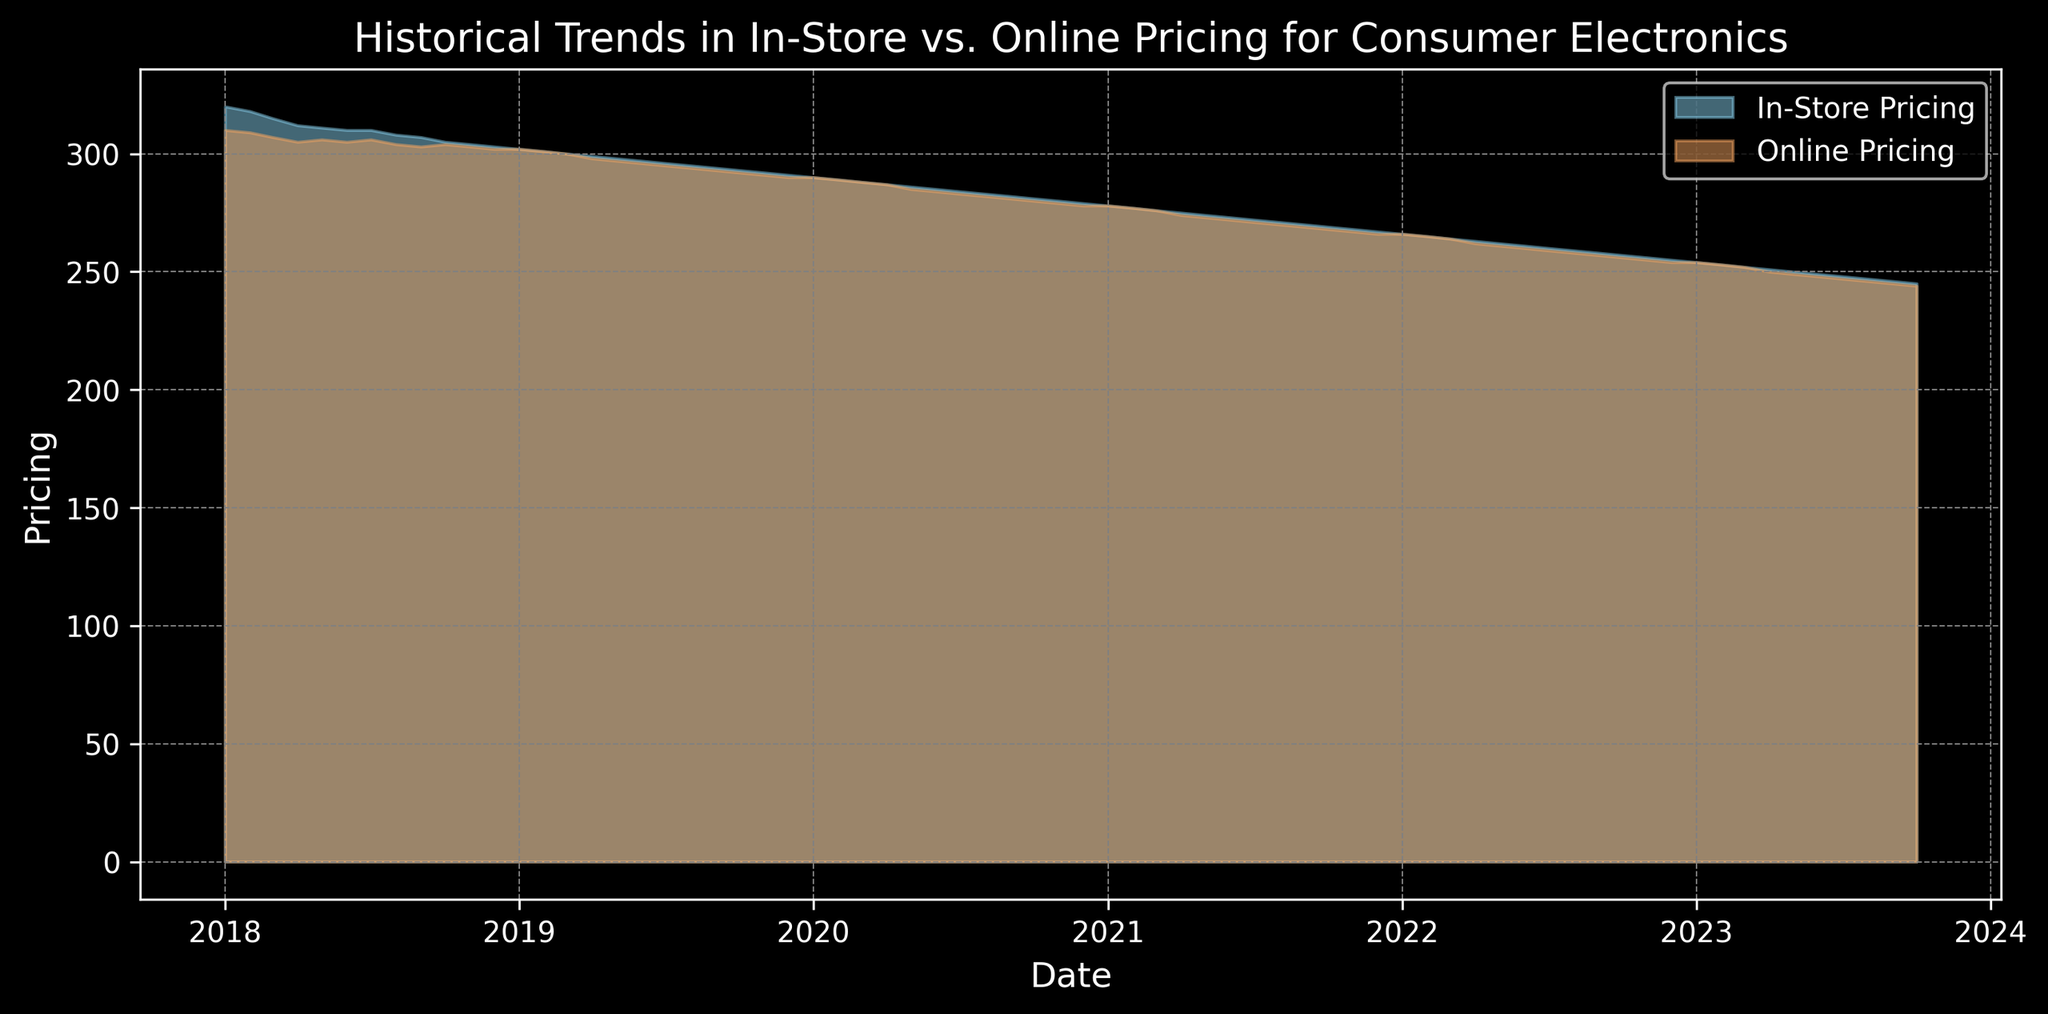What is the overall trend in both in-store and online pricing from 2018 to 2023? To identify the overall trend, observe the general direction of both pricing curves from beginning to end. Both in-store and online prices show a consistent decline over the period from 2018 to 2023.
Answer: Declining At which point do in-store and online pricing equalize? Look for the point on the x-axis where the two curves meet. According to the chart, the in-store and online pricing equalize around January 2019 and January 2020.
Answer: January 2019, January 2020 Which pricing method shows a greater decline from January 2018 to October 2023? To determine the greater decline, calculate the difference between the starting and ending points for both curves. In-Store Pricing drops from 320 to 245 (a decrease of 75), and Online Pricing drops from 310 to 244 (a decrease of 66). Thus, in-store pricing shows a greater decline.
Answer: In-Store Pricing What is the difference between in-store and online pricing in July 2018? Locate July 2018 on the x-axis and find the corresponding values for both curves. In-Store Pricing is 310, and Online Pricing is 306. The difference is computed as 310 - 306.
Answer: 4 During which month and year do we first observe that online pricing dips below 260? Identify the point where the Online Pricing curve drops below 260 for the first time. This occurs in May 2022.
Answer: May 2022 Compare the gap between in-store and online pricing in January 2018 and January 2023. Calculate the gap for both periods separately: January 2018: 320 - 310 = 10. January 2023: 254 - 253 = 1. Then compare the two gaps.
Answer: 10 and 1 Which months in 2020 show that in-store pricing is exactly 5 units higher than online pricing? Look for points on the x-axis in 2020 where the difference between the in-store and online pricing curves is exactly 5 units. This occurs in May 2020 and June 2020.
Answer: May 2020, June 2020 How does the rate of decline in pricing change for both in-store and online during 2021? Examine the slope of both curves specifically during the year 2021. Both curves appear to have a steady decline throughout 2021. The decline is consistent without sharp drops or spikes.
Answer: Steady decline In which year does the rate of decline in online pricing appear to be the fastest? Assess the steepness of the slope of the online pricing curve for each year and identify where it is the steepest. The online pricing curve appears to decline the fastest in 2020.
Answer: 2020 What is the range of in-store pricing between 2018 and 2023? Determine the highest and lowest values of in-store pricing from the chart. The highest is 320 in January 2018, and the lowest is 245 in October 2023. Calculate the range as 320 - 245.
Answer: 75 